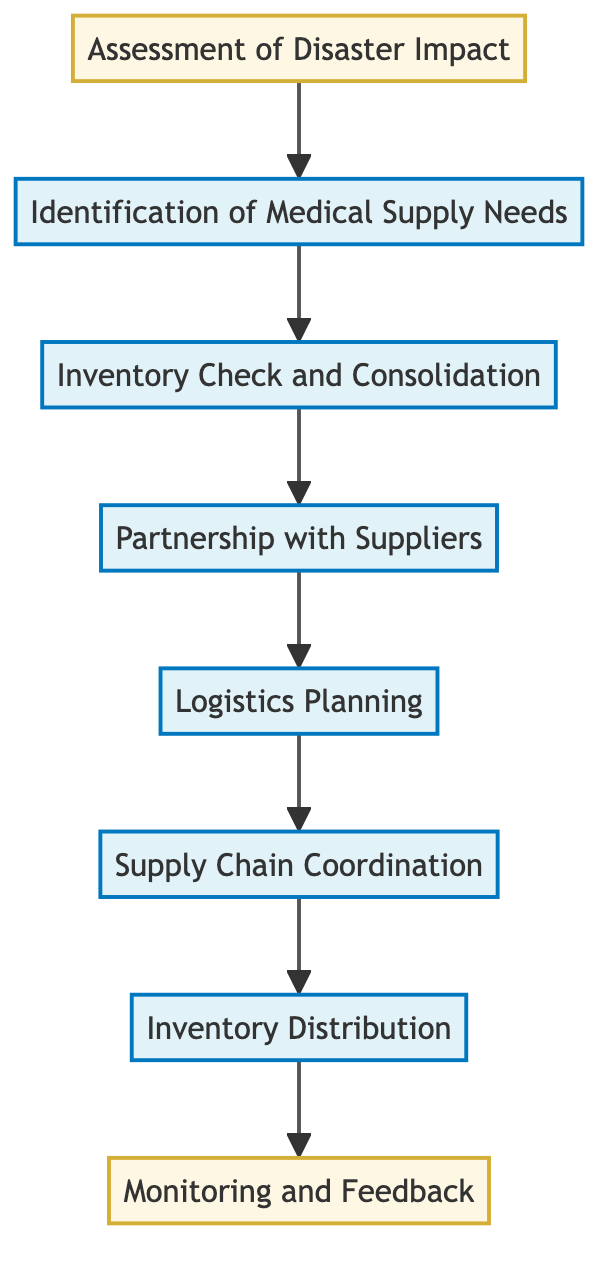What is the first step in the flow chart? The first step in the flow chart is "Assessment of Disaster Impact," which is the starting point of the medical supply chain optimization process.
Answer: Assessment of Disaster Impact How many nodes are in the flow chart? There are a total of eight nodes in the flow chart that represent different stages in the process, from assessment to feedback.
Answer: 8 What type of data does "Monitoring and Feedback" represent? "Monitoring and Feedback" is categorized as a data collection type, meaning it focuses on gathering information post-distribution to inform future efforts.
Answer: data What is the relationship between "Logistics Planning" and "Partnership with Suppliers"? "Logistics Planning" directly follows "Partnership with Suppliers," indicating that after establishing partnerships, logistics strategies are developed for resource distribution.
Answer: Logistics Planning follows Partnership with Suppliers Which step directly leads to "Inventory Distribution"? The step that directly leads to "Inventory Distribution" is "Supply Chain Coordination," indicating that coordination efforts are necessary to ensure successful distribution of medical supplies.
Answer: Supply Chain Coordination How does "Identification of Medical Supply Needs" influence the subsequent step? "Identification of Medical Supply Needs" helps determine what medical supplies are required, which informs the "Inventory Check and Consolidation" process to ensure the appropriate resources are available.
Answer: Informs Inventory Check and Consolidation What is the final step in the process? The final step in the flow chart is "Monitoring and Feedback," which indicates the conclusion of the supply chain optimization process and focuses on evaluation for future improvements.
Answer: Monitoring and Feedback Which two steps are categorized under the process type? The steps "Inventory Check and Consolidation" and "Logistics Planning" are both categorized under process type, signifying actions within the operational aspect of the supply chain.
Answer: Inventory Check and Consolidation and Logistics Planning 